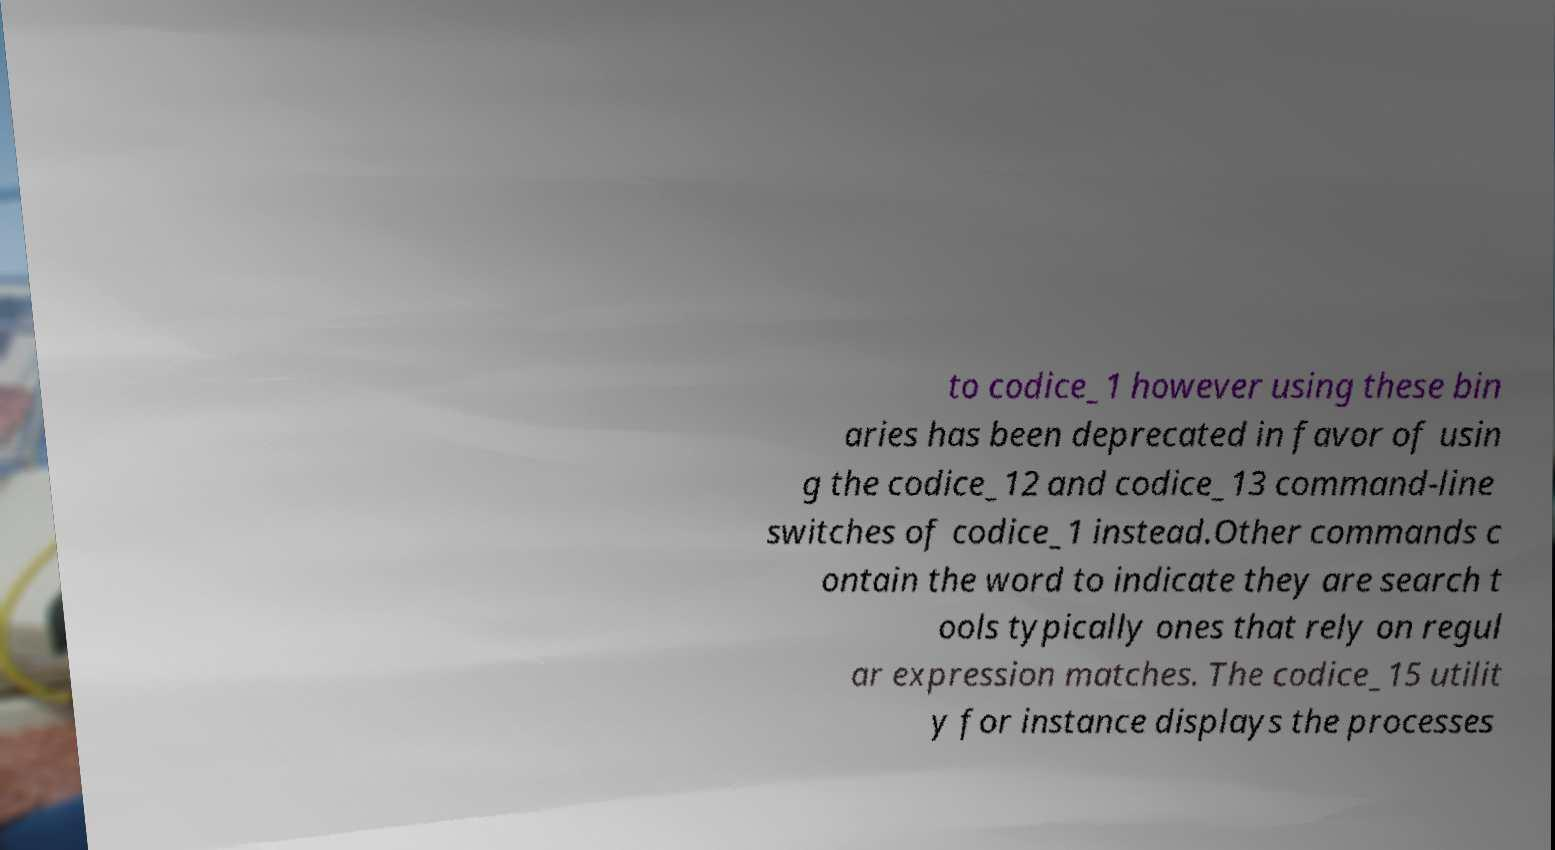Can you accurately transcribe the text from the provided image for me? to codice_1 however using these bin aries has been deprecated in favor of usin g the codice_12 and codice_13 command-line switches of codice_1 instead.Other commands c ontain the word to indicate they are search t ools typically ones that rely on regul ar expression matches. The codice_15 utilit y for instance displays the processes 